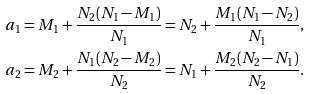<formula> <loc_0><loc_0><loc_500><loc_500>a _ { 1 } & = M _ { 1 } + \frac { N _ { 2 } ( N _ { 1 } - M _ { 1 } ) } { N _ { 1 } } = N _ { 2 } + \frac { M _ { 1 } ( N _ { 1 } - N _ { 2 } ) } { N _ { 1 } } , \\ a _ { 2 } & = M _ { 2 } + \frac { N _ { 1 } ( N _ { 2 } - M _ { 2 } ) } { N _ { 2 } } = N _ { 1 } + \frac { M _ { 2 } ( N _ { 2 } - N _ { 1 } ) } { N _ { 2 } } .</formula> 